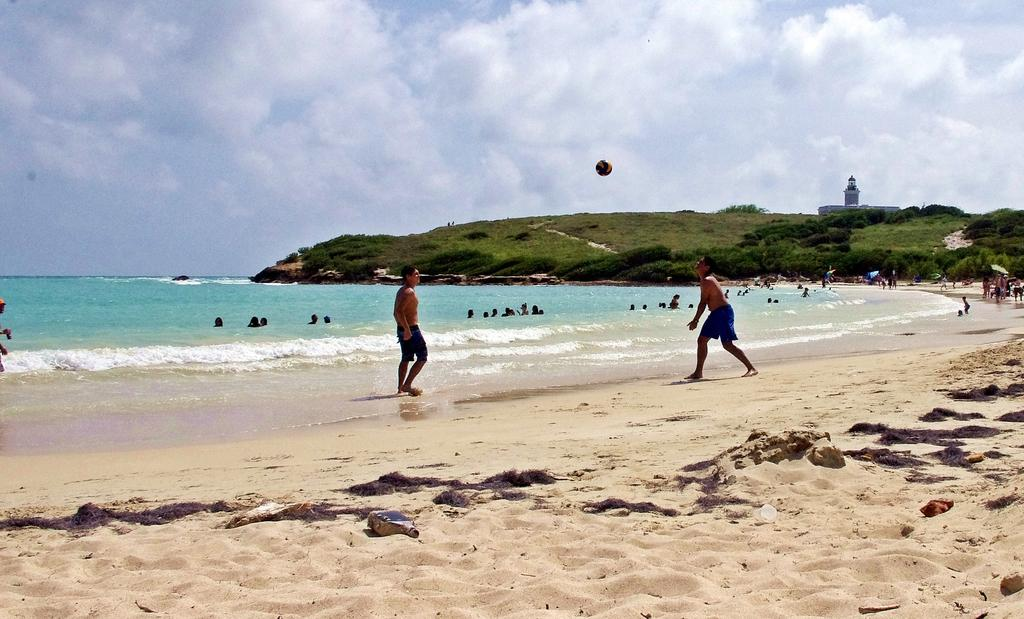What is the weather like in the image? The sky is cloudy in the image. What object is in the air? A ball is in the air in the image. What type of terrain is visible in the image? Soil and water are visible in the image. Are there any people in the image? Yes, there are people in the image. What are some people doing in the image? Some people are in the water. What can be seen in the distance in the image? There is a building, grass, and plants in the distance. What type of flower is being watered by the maid in the image? There is no maid or flower present in the image. Where is the faucet located in the image? There is no faucet present in the image. 